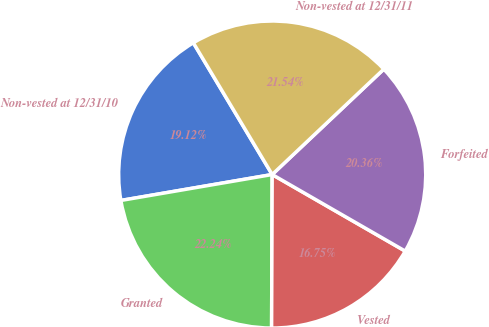<chart> <loc_0><loc_0><loc_500><loc_500><pie_chart><fcel>Non-vested at 12/31/10<fcel>Granted<fcel>Vested<fcel>Forfeited<fcel>Non-vested at 12/31/11<nl><fcel>19.12%<fcel>22.24%<fcel>16.75%<fcel>20.36%<fcel>21.54%<nl></chart> 